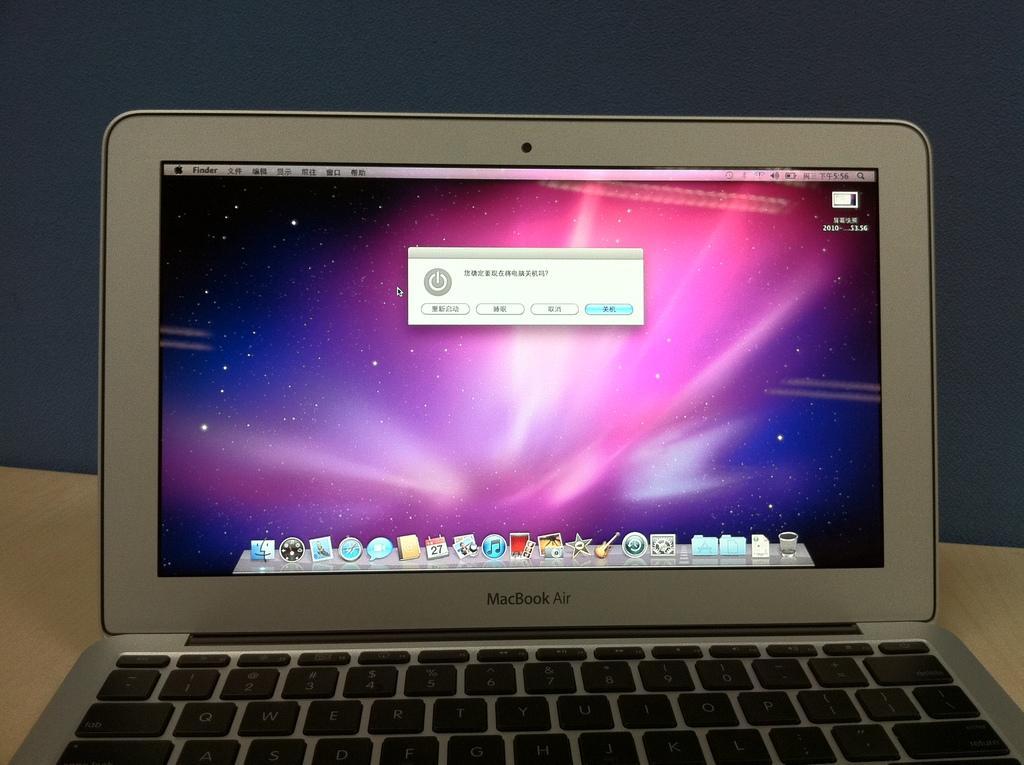Can you describe this image briefly? In this image we can see a laptop placed on the table. 